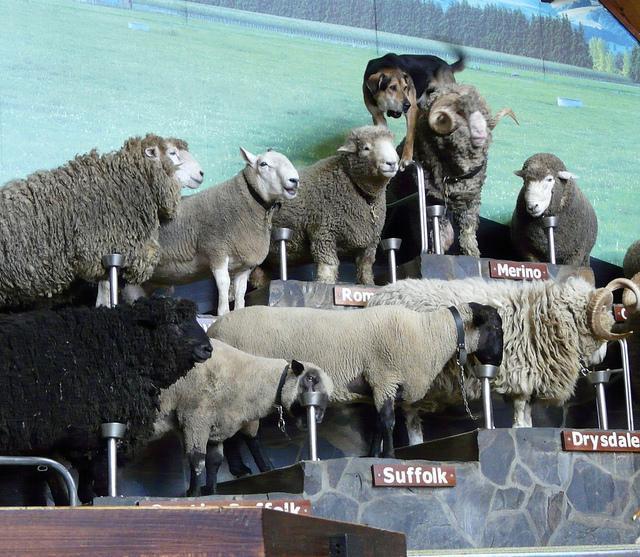Which type of sheep is the highest on the stand?
Indicate the correct choice and explain in the format: 'Answer: answer
Rationale: rationale.'
Options: Drysdale, suffolk, roma, merino. Answer: merino.
Rationale: The sign is under the one at the very top that shows what kind it is. What is at the top of the sheep pile?
Select the accurate response from the four choices given to answer the question.
Options: Dog, elephant, baby, mouse. Dog. 